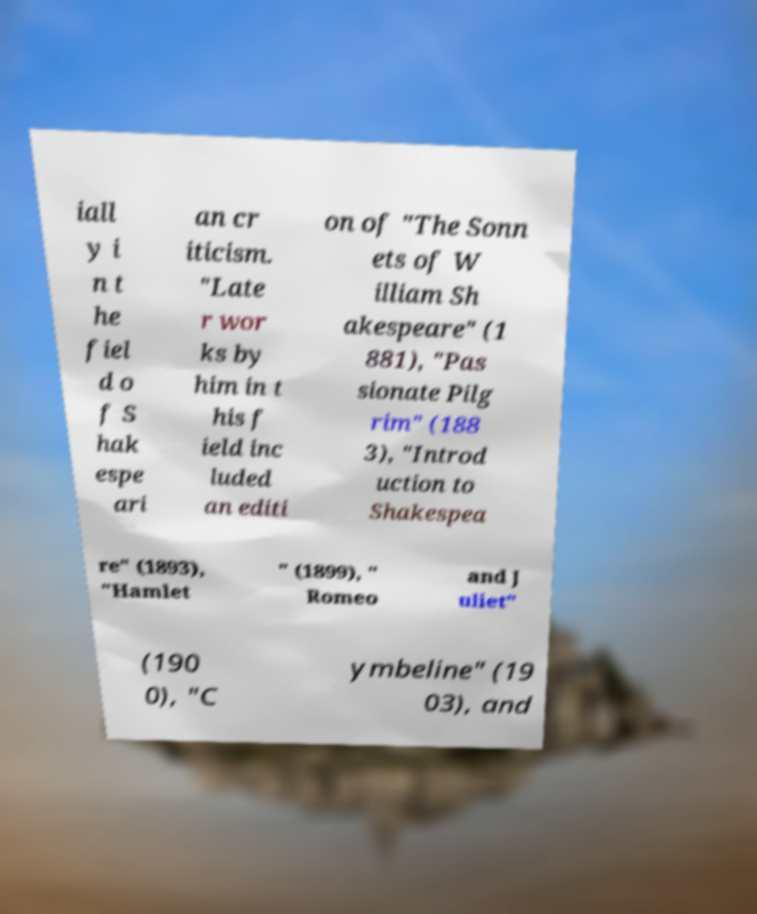Could you extract and type out the text from this image? iall y i n t he fiel d o f S hak espe ari an cr iticism. "Late r wor ks by him in t his f ield inc luded an editi on of "The Sonn ets of W illiam Sh akespeare" (1 881), "Pas sionate Pilg rim" (188 3), "Introd uction to Shakespea re" (1893), "Hamlet " (1899), " Romeo and J uliet" (190 0), "C ymbeline" (19 03), and 